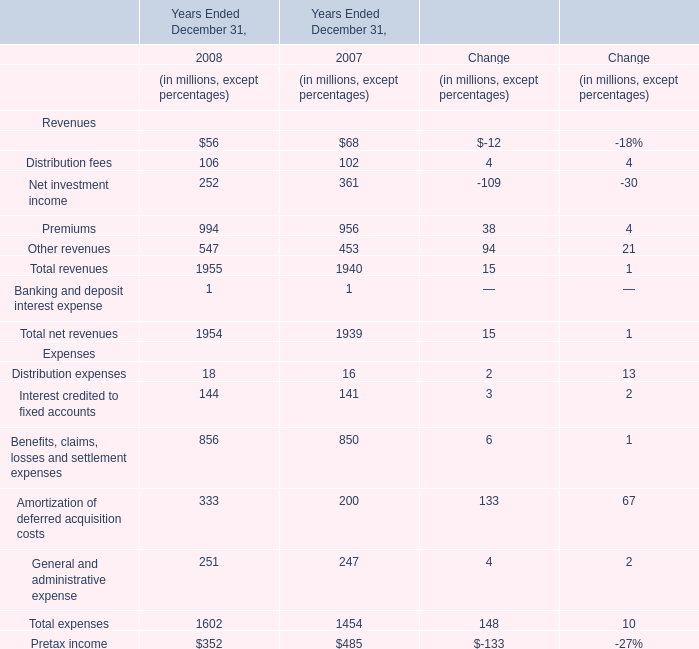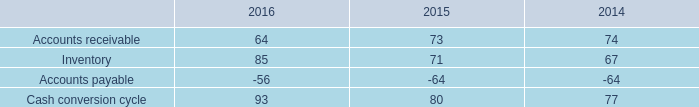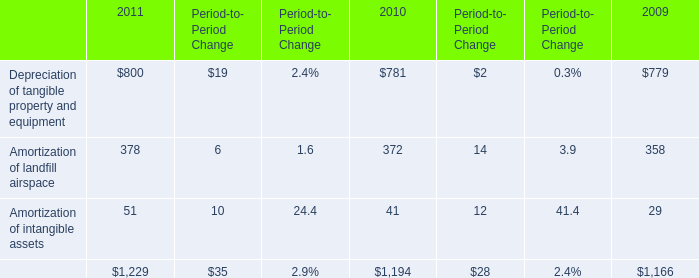What's the average of Distribution fees in 2008 and 2007? (in millions) 
Computations: ((106 + 102) / 2)
Answer: 104.0. 